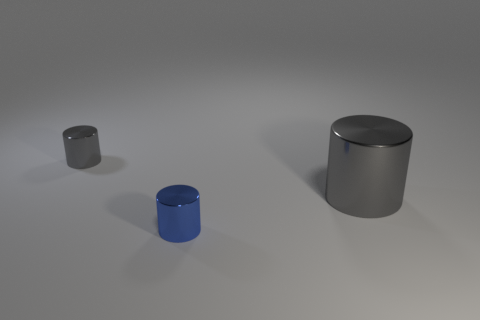How many things are tiny gray objects or gray metal cylinders on the right side of the small blue thing?
Your answer should be compact. 2. Are there any other shiny things of the same color as the big object?
Keep it short and to the point. Yes. How many yellow objects are tiny shiny objects or big cylinders?
Offer a terse response. 0. How many other things are the same size as the blue metal object?
Offer a very short reply. 1. What number of tiny objects are either blue cylinders or gray shiny cylinders?
Keep it short and to the point. 2. Do the blue shiny thing and the metallic thing on the right side of the small blue metallic cylinder have the same size?
Offer a very short reply. No. How many other things are the same shape as the large thing?
Offer a very short reply. 2. Is there a yellow metallic sphere?
Keep it short and to the point. No. Are there fewer big metal objects that are to the left of the blue cylinder than blue metallic cylinders on the left side of the small gray object?
Provide a succinct answer. No. There is a gray object behind the big gray metallic object; what shape is it?
Give a very brief answer. Cylinder. 